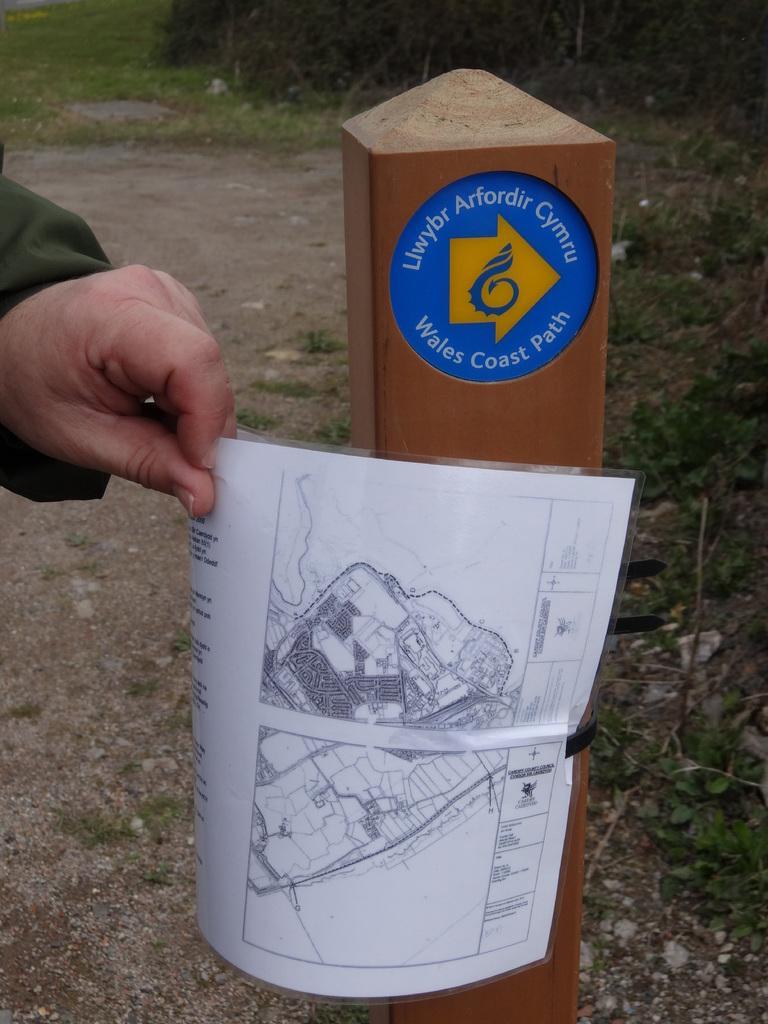How would you summarize this image in a sentence or two? In this picture we can see hand of a person holding a paper. There is a wooden stick. In the background we can see grass. 